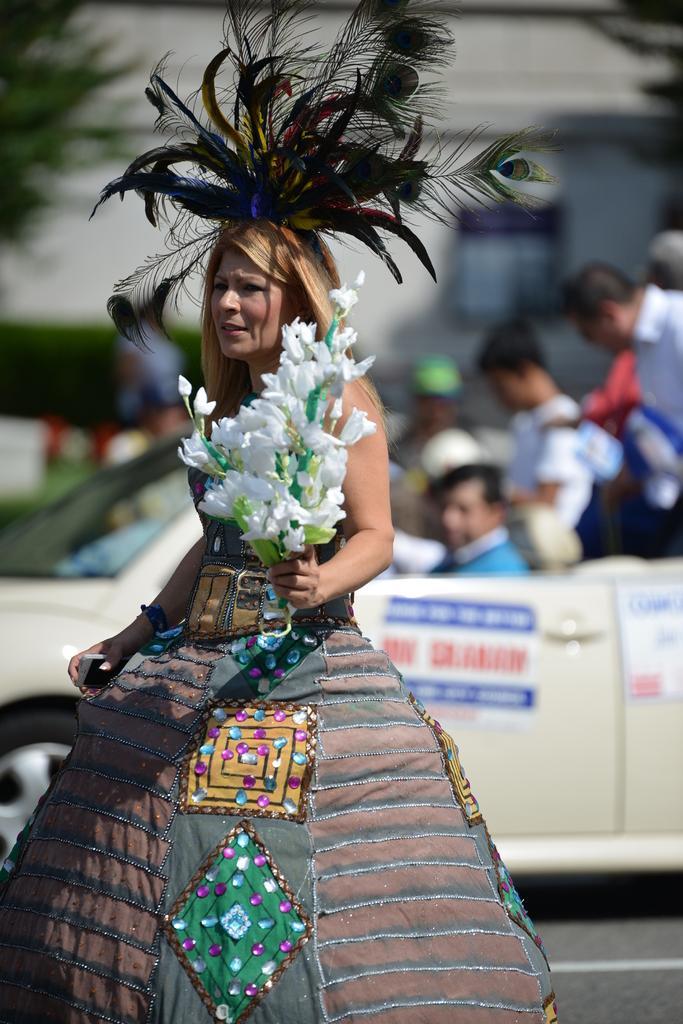Could you give a brief overview of what you see in this image? In this image we can see a woman standing on the road by wearing a costume and holding a bunch of flowers in the hands. In the background we can see people sitting in the motor vehicle, building and trees. 